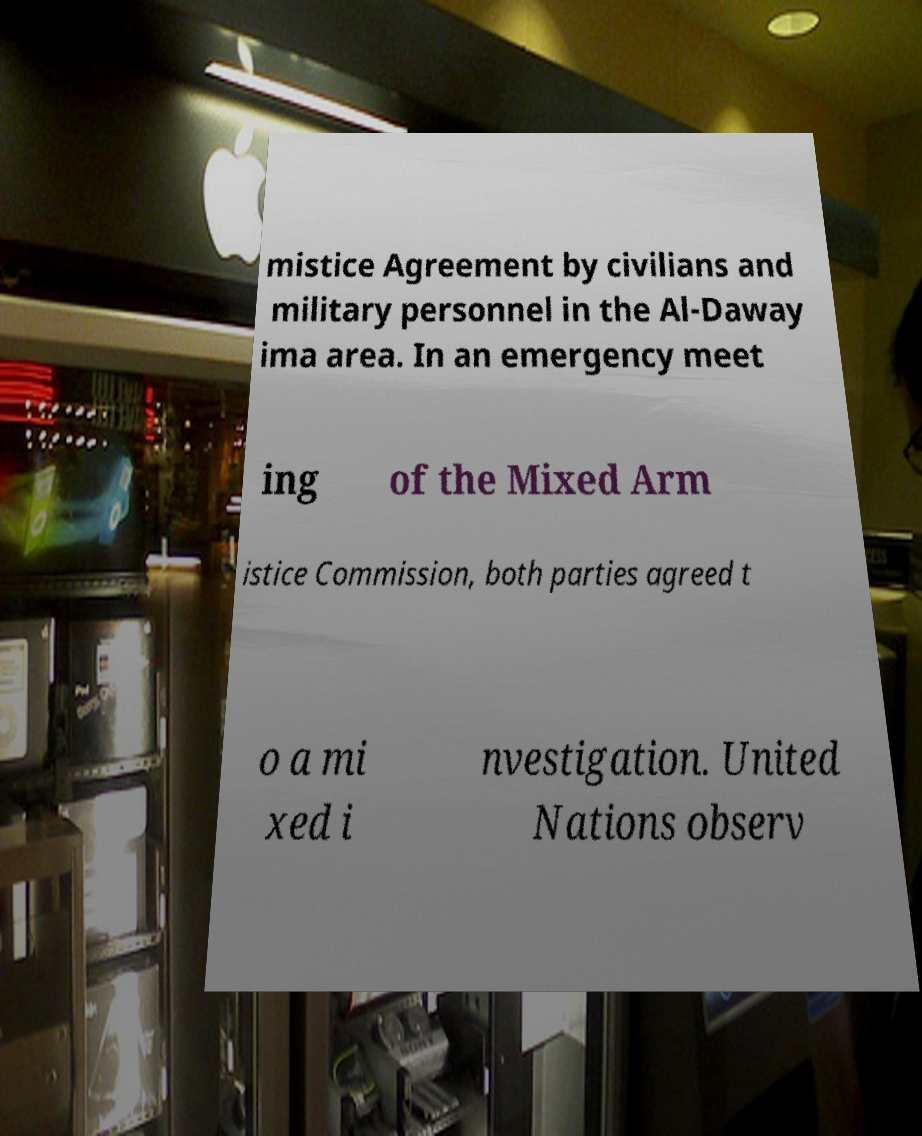Please read and relay the text visible in this image. What does it say? mistice Agreement by civilians and military personnel in the Al-Daway ima area. In an emergency meet ing of the Mixed Arm istice Commission, both parties agreed t o a mi xed i nvestigation. United Nations observ 